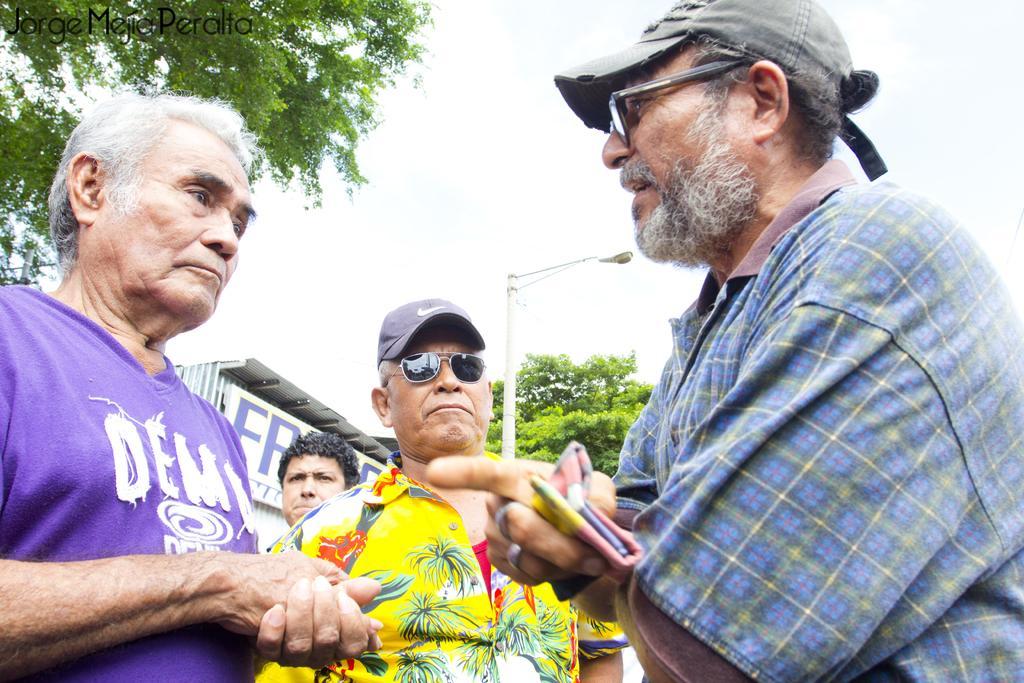Could you give a brief overview of what you see in this image? In this image we can see people standing. In the background there is a shed and a pole. We can see trees and sky. 